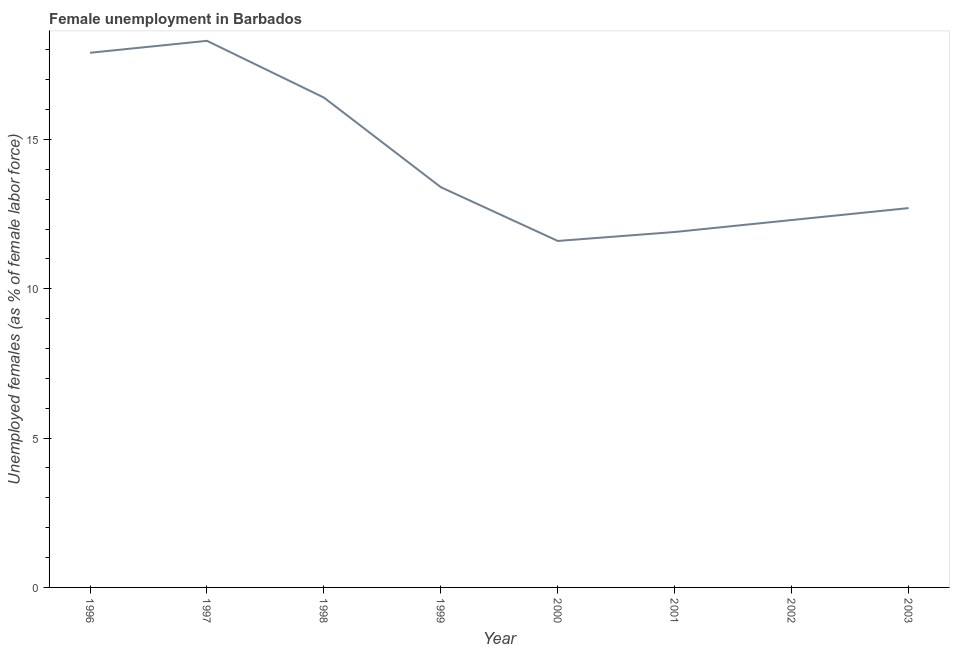What is the unemployed females population in 2003?
Offer a terse response. 12.7. Across all years, what is the maximum unemployed females population?
Your response must be concise. 18.3. Across all years, what is the minimum unemployed females population?
Make the answer very short. 11.6. In which year was the unemployed females population minimum?
Keep it short and to the point. 2000. What is the sum of the unemployed females population?
Ensure brevity in your answer.  114.5. What is the difference between the unemployed females population in 2001 and 2003?
Offer a very short reply. -0.8. What is the average unemployed females population per year?
Provide a succinct answer. 14.31. What is the median unemployed females population?
Ensure brevity in your answer.  13.05. In how many years, is the unemployed females population greater than 10 %?
Keep it short and to the point. 8. Do a majority of the years between 1996 and 1997 (inclusive) have unemployed females population greater than 1 %?
Provide a succinct answer. Yes. What is the ratio of the unemployed females population in 1999 to that in 2001?
Ensure brevity in your answer.  1.13. Is the difference between the unemployed females population in 2000 and 2001 greater than the difference between any two years?
Your answer should be compact. No. What is the difference between the highest and the second highest unemployed females population?
Your answer should be very brief. 0.4. What is the difference between the highest and the lowest unemployed females population?
Your answer should be compact. 6.7. How many years are there in the graph?
Your answer should be compact. 8. What is the difference between two consecutive major ticks on the Y-axis?
Your response must be concise. 5. Are the values on the major ticks of Y-axis written in scientific E-notation?
Make the answer very short. No. Does the graph contain grids?
Your response must be concise. No. What is the title of the graph?
Offer a very short reply. Female unemployment in Barbados. What is the label or title of the Y-axis?
Ensure brevity in your answer.  Unemployed females (as % of female labor force). What is the Unemployed females (as % of female labor force) in 1996?
Your answer should be compact. 17.9. What is the Unemployed females (as % of female labor force) in 1997?
Your answer should be very brief. 18.3. What is the Unemployed females (as % of female labor force) of 1998?
Make the answer very short. 16.4. What is the Unemployed females (as % of female labor force) in 1999?
Ensure brevity in your answer.  13.4. What is the Unemployed females (as % of female labor force) of 2000?
Offer a very short reply. 11.6. What is the Unemployed females (as % of female labor force) in 2001?
Your response must be concise. 11.9. What is the Unemployed females (as % of female labor force) of 2002?
Offer a terse response. 12.3. What is the Unemployed females (as % of female labor force) in 2003?
Ensure brevity in your answer.  12.7. What is the difference between the Unemployed females (as % of female labor force) in 1996 and 1998?
Offer a terse response. 1.5. What is the difference between the Unemployed females (as % of female labor force) in 1996 and 2002?
Provide a succinct answer. 5.6. What is the difference between the Unemployed females (as % of female labor force) in 1996 and 2003?
Make the answer very short. 5.2. What is the difference between the Unemployed females (as % of female labor force) in 1997 and 2000?
Offer a terse response. 6.7. What is the difference between the Unemployed females (as % of female labor force) in 1997 and 2001?
Keep it short and to the point. 6.4. What is the difference between the Unemployed females (as % of female labor force) in 1998 and 2001?
Offer a very short reply. 4.5. What is the difference between the Unemployed females (as % of female labor force) in 1999 and 2000?
Provide a succinct answer. 1.8. What is the difference between the Unemployed females (as % of female labor force) in 1999 and 2001?
Keep it short and to the point. 1.5. What is the difference between the Unemployed females (as % of female labor force) in 1999 and 2002?
Your response must be concise. 1.1. What is the difference between the Unemployed females (as % of female labor force) in 2000 and 2002?
Provide a short and direct response. -0.7. What is the difference between the Unemployed females (as % of female labor force) in 2001 and 2002?
Your answer should be very brief. -0.4. What is the difference between the Unemployed females (as % of female labor force) in 2002 and 2003?
Your answer should be very brief. -0.4. What is the ratio of the Unemployed females (as % of female labor force) in 1996 to that in 1997?
Your answer should be very brief. 0.98. What is the ratio of the Unemployed females (as % of female labor force) in 1996 to that in 1998?
Ensure brevity in your answer.  1.09. What is the ratio of the Unemployed females (as % of female labor force) in 1996 to that in 1999?
Provide a short and direct response. 1.34. What is the ratio of the Unemployed females (as % of female labor force) in 1996 to that in 2000?
Provide a short and direct response. 1.54. What is the ratio of the Unemployed females (as % of female labor force) in 1996 to that in 2001?
Offer a very short reply. 1.5. What is the ratio of the Unemployed females (as % of female labor force) in 1996 to that in 2002?
Give a very brief answer. 1.46. What is the ratio of the Unemployed females (as % of female labor force) in 1996 to that in 2003?
Provide a short and direct response. 1.41. What is the ratio of the Unemployed females (as % of female labor force) in 1997 to that in 1998?
Ensure brevity in your answer.  1.12. What is the ratio of the Unemployed females (as % of female labor force) in 1997 to that in 1999?
Give a very brief answer. 1.37. What is the ratio of the Unemployed females (as % of female labor force) in 1997 to that in 2000?
Your answer should be very brief. 1.58. What is the ratio of the Unemployed females (as % of female labor force) in 1997 to that in 2001?
Offer a very short reply. 1.54. What is the ratio of the Unemployed females (as % of female labor force) in 1997 to that in 2002?
Your response must be concise. 1.49. What is the ratio of the Unemployed females (as % of female labor force) in 1997 to that in 2003?
Provide a short and direct response. 1.44. What is the ratio of the Unemployed females (as % of female labor force) in 1998 to that in 1999?
Offer a very short reply. 1.22. What is the ratio of the Unemployed females (as % of female labor force) in 1998 to that in 2000?
Make the answer very short. 1.41. What is the ratio of the Unemployed females (as % of female labor force) in 1998 to that in 2001?
Your answer should be compact. 1.38. What is the ratio of the Unemployed females (as % of female labor force) in 1998 to that in 2002?
Keep it short and to the point. 1.33. What is the ratio of the Unemployed females (as % of female labor force) in 1998 to that in 2003?
Give a very brief answer. 1.29. What is the ratio of the Unemployed females (as % of female labor force) in 1999 to that in 2000?
Give a very brief answer. 1.16. What is the ratio of the Unemployed females (as % of female labor force) in 1999 to that in 2001?
Your response must be concise. 1.13. What is the ratio of the Unemployed females (as % of female labor force) in 1999 to that in 2002?
Offer a very short reply. 1.09. What is the ratio of the Unemployed females (as % of female labor force) in 1999 to that in 2003?
Your answer should be compact. 1.05. What is the ratio of the Unemployed females (as % of female labor force) in 2000 to that in 2001?
Ensure brevity in your answer.  0.97. What is the ratio of the Unemployed females (as % of female labor force) in 2000 to that in 2002?
Your response must be concise. 0.94. What is the ratio of the Unemployed females (as % of female labor force) in 2000 to that in 2003?
Make the answer very short. 0.91. What is the ratio of the Unemployed females (as % of female labor force) in 2001 to that in 2002?
Offer a terse response. 0.97. What is the ratio of the Unemployed females (as % of female labor force) in 2001 to that in 2003?
Make the answer very short. 0.94. 